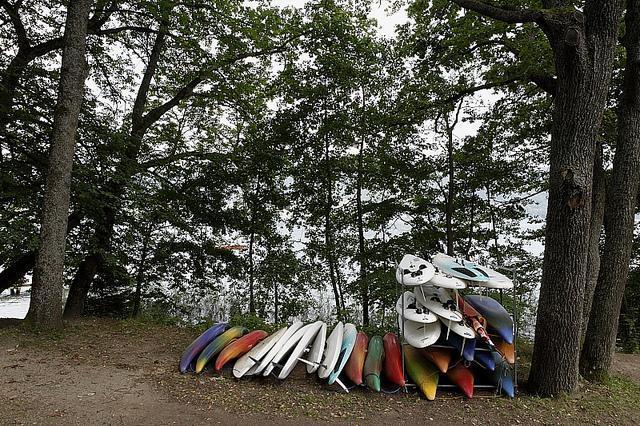How many people are here?
Give a very brief answer. 0. 